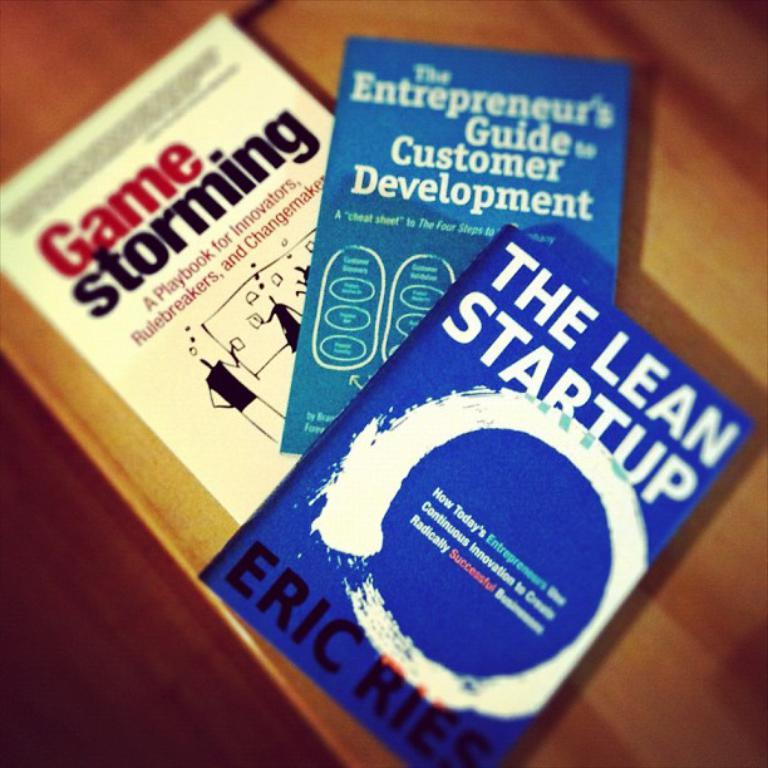<image>
Relay a brief, clear account of the picture shown. Three books on the table and the author of the blue one is Eric Ries. 